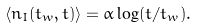Convert formula to latex. <formula><loc_0><loc_0><loc_500><loc_500>\langle n _ { I } ( t _ { w } , t ) \rangle = \alpha \log ( t / t _ { w } ) .</formula> 